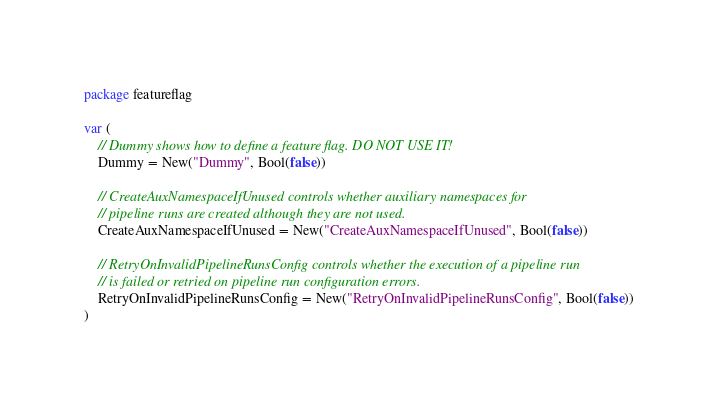Convert code to text. <code><loc_0><loc_0><loc_500><loc_500><_Go_>package featureflag

var (
	// Dummy shows how to define a feature flag. DO NOT USE IT!
	Dummy = New("Dummy", Bool(false))

	// CreateAuxNamespaceIfUnused controls whether auxiliary namespaces for
	// pipeline runs are created although they are not used.
	CreateAuxNamespaceIfUnused = New("CreateAuxNamespaceIfUnused", Bool(false))

	// RetryOnInvalidPipelineRunsConfig controls whether the execution of a pipeline run
	// is failed or retried on pipeline run configuration errors.
	RetryOnInvalidPipelineRunsConfig = New("RetryOnInvalidPipelineRunsConfig", Bool(false))
)
</code> 